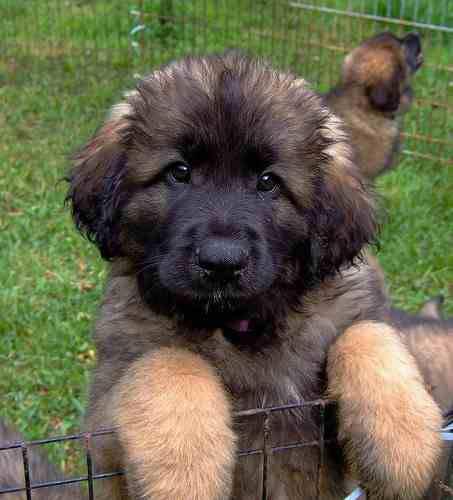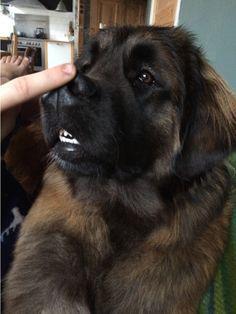The first image is the image on the left, the second image is the image on the right. Given the left and right images, does the statement "A puppy sits upright with its front paws hanging over something else." hold true? Answer yes or no. Yes. The first image is the image on the left, the second image is the image on the right. For the images displayed, is the sentence "The left photo depicts a puppy with its front paws propped up on something." factually correct? Answer yes or no. Yes. 